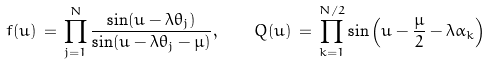<formula> <loc_0><loc_0><loc_500><loc_500>f ( u ) \, = \, \prod _ { j = 1 } ^ { N } \frac { \sin ( u - \lambda \theta _ { j } ) } { \sin ( u - \lambda \theta _ { j } - \mu ) } , \quad Q ( u ) \, = \, \prod _ { k = 1 } ^ { N / 2 } \sin \left ( u - \frac { \mu } { 2 } - \lambda \alpha _ { k } \right )</formula> 